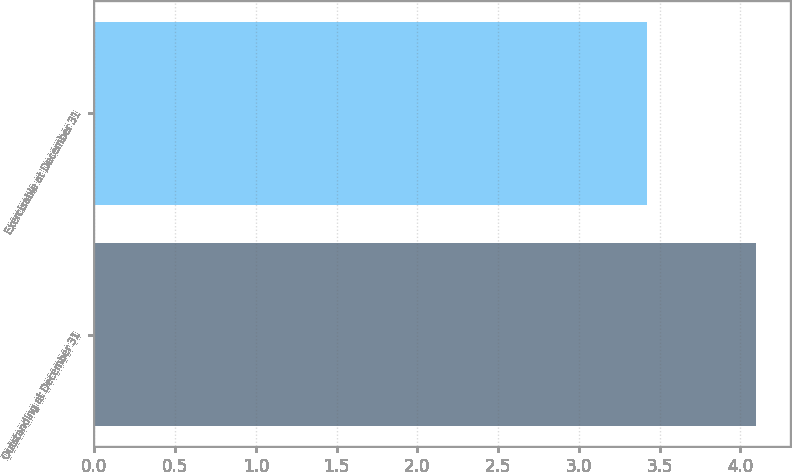Convert chart to OTSL. <chart><loc_0><loc_0><loc_500><loc_500><bar_chart><fcel>Outstanding at December 31<fcel>Exercisable at December 31<nl><fcel>4.1<fcel>3.42<nl></chart> 